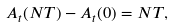Convert formula to latex. <formula><loc_0><loc_0><loc_500><loc_500>A _ { t } ( N T ) - A _ { t } ( 0 ) = N T ,</formula> 